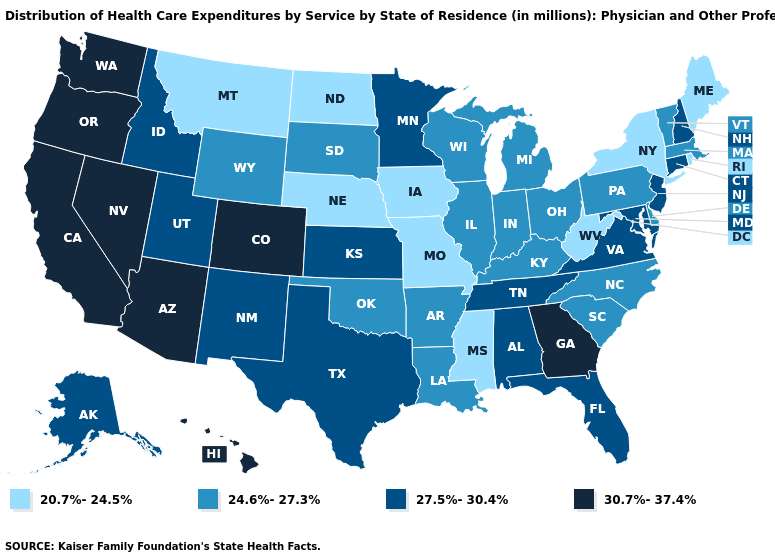What is the value of Colorado?
Keep it brief. 30.7%-37.4%. Which states hav the highest value in the South?
Short answer required. Georgia. What is the lowest value in the West?
Be succinct. 20.7%-24.5%. Name the states that have a value in the range 20.7%-24.5%?
Short answer required. Iowa, Maine, Mississippi, Missouri, Montana, Nebraska, New York, North Dakota, Rhode Island, West Virginia. What is the value of Pennsylvania?
Answer briefly. 24.6%-27.3%. Name the states that have a value in the range 27.5%-30.4%?
Quick response, please. Alabama, Alaska, Connecticut, Florida, Idaho, Kansas, Maryland, Minnesota, New Hampshire, New Jersey, New Mexico, Tennessee, Texas, Utah, Virginia. Name the states that have a value in the range 27.5%-30.4%?
Quick response, please. Alabama, Alaska, Connecticut, Florida, Idaho, Kansas, Maryland, Minnesota, New Hampshire, New Jersey, New Mexico, Tennessee, Texas, Utah, Virginia. What is the highest value in the USA?
Be succinct. 30.7%-37.4%. How many symbols are there in the legend?
Concise answer only. 4. Name the states that have a value in the range 20.7%-24.5%?
Concise answer only. Iowa, Maine, Mississippi, Missouri, Montana, Nebraska, New York, North Dakota, Rhode Island, West Virginia. How many symbols are there in the legend?
Write a very short answer. 4. Name the states that have a value in the range 24.6%-27.3%?
Answer briefly. Arkansas, Delaware, Illinois, Indiana, Kentucky, Louisiana, Massachusetts, Michigan, North Carolina, Ohio, Oklahoma, Pennsylvania, South Carolina, South Dakota, Vermont, Wisconsin, Wyoming. What is the lowest value in the USA?
Write a very short answer. 20.7%-24.5%. Does Washington have the highest value in the USA?
Answer briefly. Yes. What is the lowest value in states that border Maine?
Keep it brief. 27.5%-30.4%. 